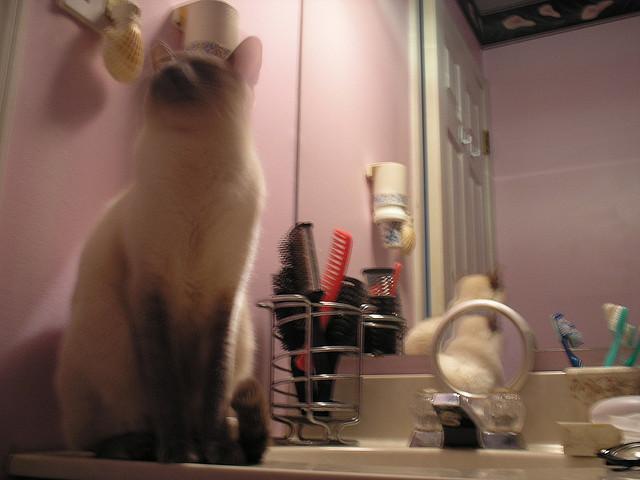How many toothbrush do you see?
Give a very brief answer. 2. How many cats are there?
Give a very brief answer. 2. 